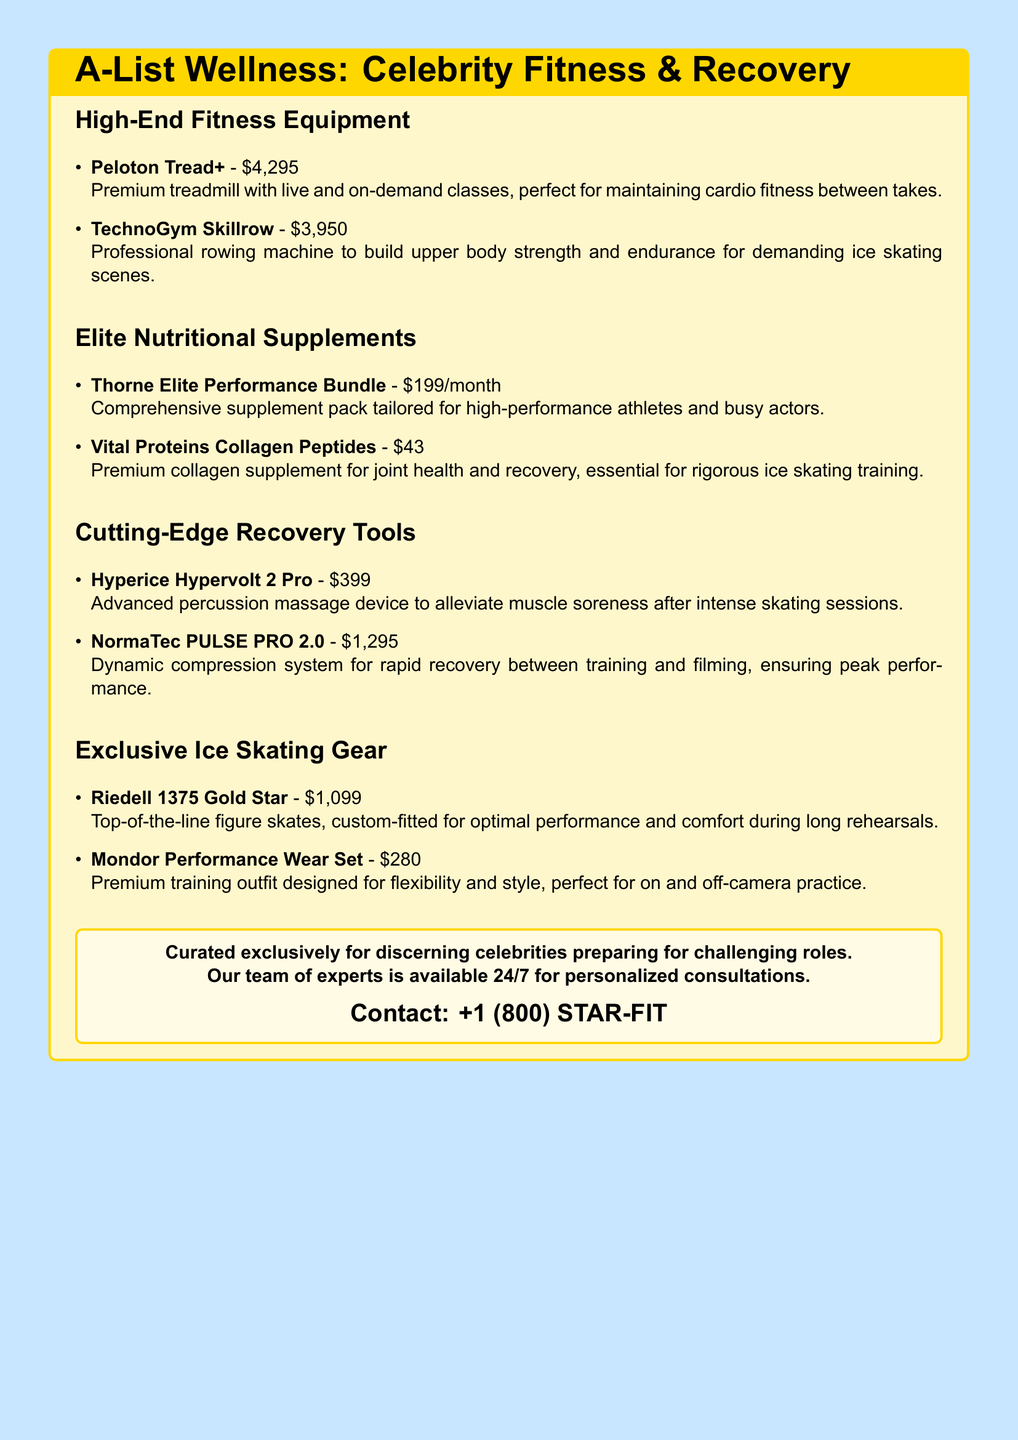What is the price of the Peloton Tread+? The price of the Peloton Tread+ is explicitly listed in the document as $4,295.
Answer: $4,295 What is included in the Thorne Elite Performance Bundle? The document describes it as a comprehensive supplement pack tailored for high-performance athletes and busy actors without detailing specific ingredients.
Answer: Comprehensive supplement pack How much does the NormaTec PULSE PRO 2.0 cost? The cost is clearly noted in the document as $1,295.
Answer: $1,295 Which recovery tool is an advanced percussion massage device? The document specifies that the Hyperice Hypervolt 2 Pro is the advanced percussion massage device.
Answer: Hyperice Hypervolt 2 Pro What type of skates are the Riedell 1375 Gold Star? The document categorizes these skates as top-of-the-line figure skates.
Answer: Figure skates Which product is specifically for joint health and recovery? The document indicates that Vital Proteins Collagen Peptides is for joint health and recovery.
Answer: Vital Proteins Collagen Peptides What is the main function of the TechnoGym Skillrow? The document states that it is used to build upper body strength and endurance.
Answer: Build upper body strength How much does the Mondor Performance Wear Set cost? The cost is found in the document, showing it as $280.
Answer: $280 What service is offered 24/7 according to the catalog? The document mentions personalized consultations as the service available 24/7.
Answer: Personalized consultations 